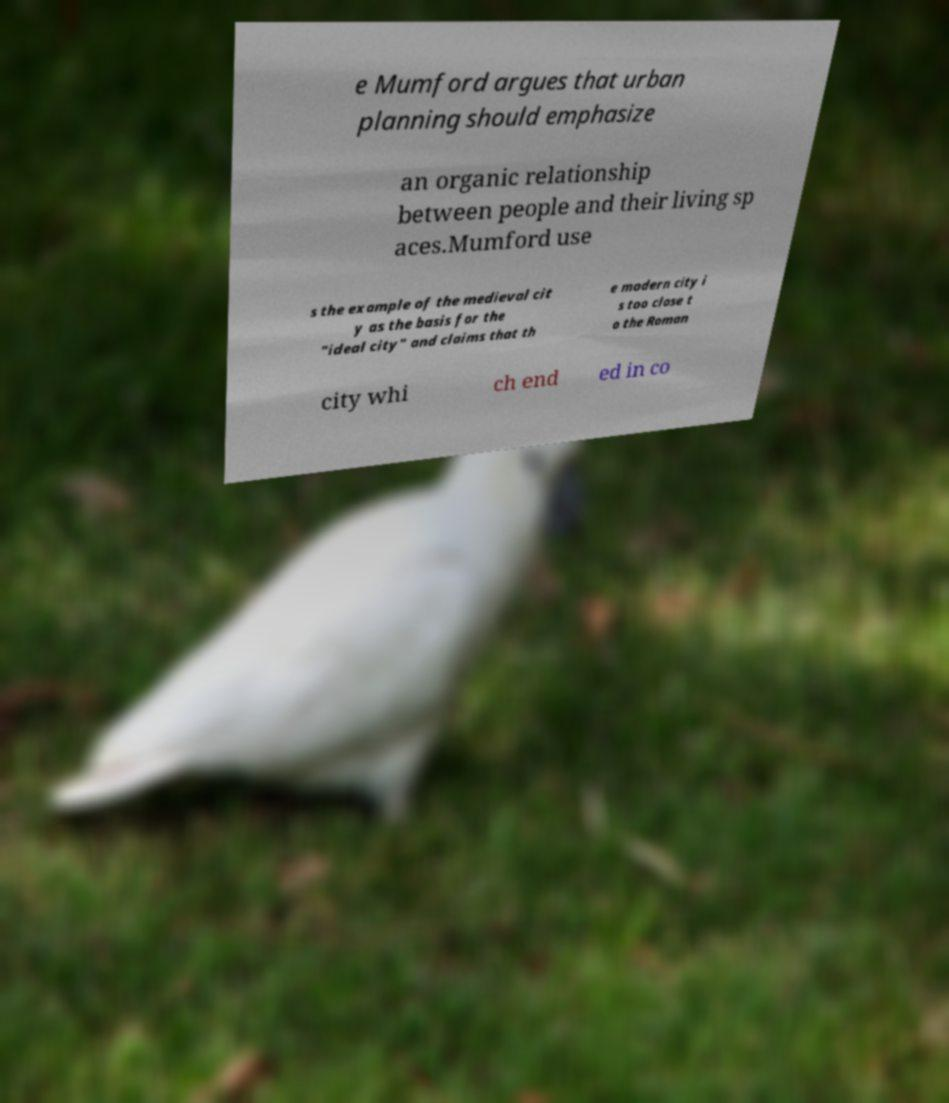Please identify and transcribe the text found in this image. e Mumford argues that urban planning should emphasize an organic relationship between people and their living sp aces.Mumford use s the example of the medieval cit y as the basis for the "ideal city" and claims that th e modern city i s too close t o the Roman city whi ch end ed in co 